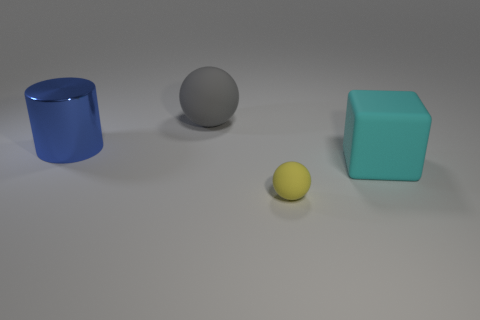What might be the context or usage of these objects? These objects appear to be simple geometric shapes, possibly used for educational purposes to teach about colors and shapes, or as part of a computer graphics rendering test to assess shading and lighting. 